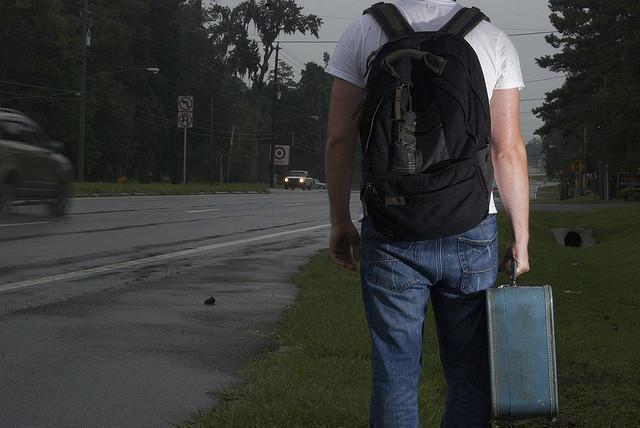What does the backpacking man hope for?
Indicate the correct response and explain using: 'Answer: answer
Rationale: rationale.'
Options: Ride, nothing, dinner, motor bike. Answer: ride.
Rationale: The man is walking on the side of the road with a backpack and a suitcase. the man is hitchhiking. 